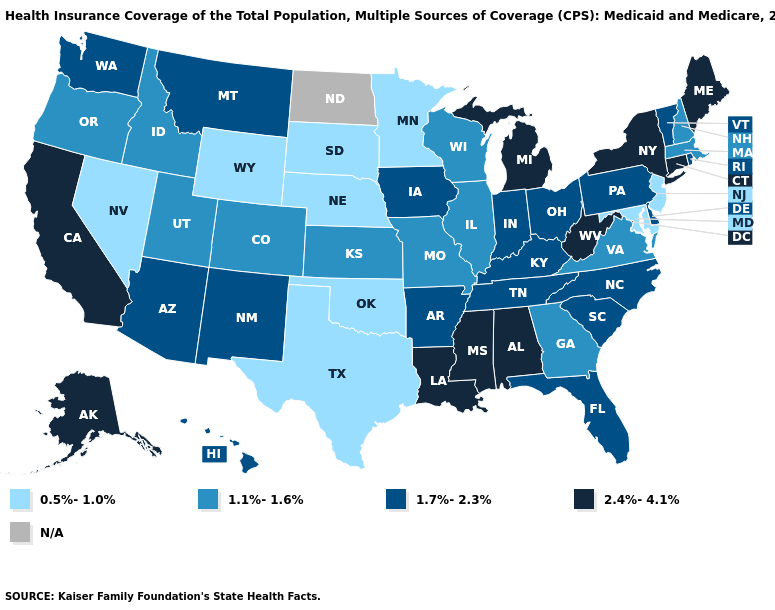What is the value of Louisiana?
Be succinct. 2.4%-4.1%. Does the first symbol in the legend represent the smallest category?
Give a very brief answer. Yes. Name the states that have a value in the range 0.5%-1.0%?
Give a very brief answer. Maryland, Minnesota, Nebraska, Nevada, New Jersey, Oklahoma, South Dakota, Texas, Wyoming. What is the lowest value in the West?
Write a very short answer. 0.5%-1.0%. Which states hav the highest value in the Northeast?
Be succinct. Connecticut, Maine, New York. How many symbols are there in the legend?
Be succinct. 5. What is the value of Illinois?
Concise answer only. 1.1%-1.6%. What is the value of Rhode Island?
Keep it brief. 1.7%-2.3%. Does Michigan have the highest value in the MidWest?
Quick response, please. Yes. What is the value of Minnesota?
Concise answer only. 0.5%-1.0%. Does Nevada have the lowest value in the USA?
Concise answer only. Yes. What is the value of Kansas?
Be succinct. 1.1%-1.6%. Does Wyoming have the lowest value in the West?
Concise answer only. Yes. What is the value of Alabama?
Keep it brief. 2.4%-4.1%. Does Arizona have the highest value in the USA?
Keep it brief. No. 